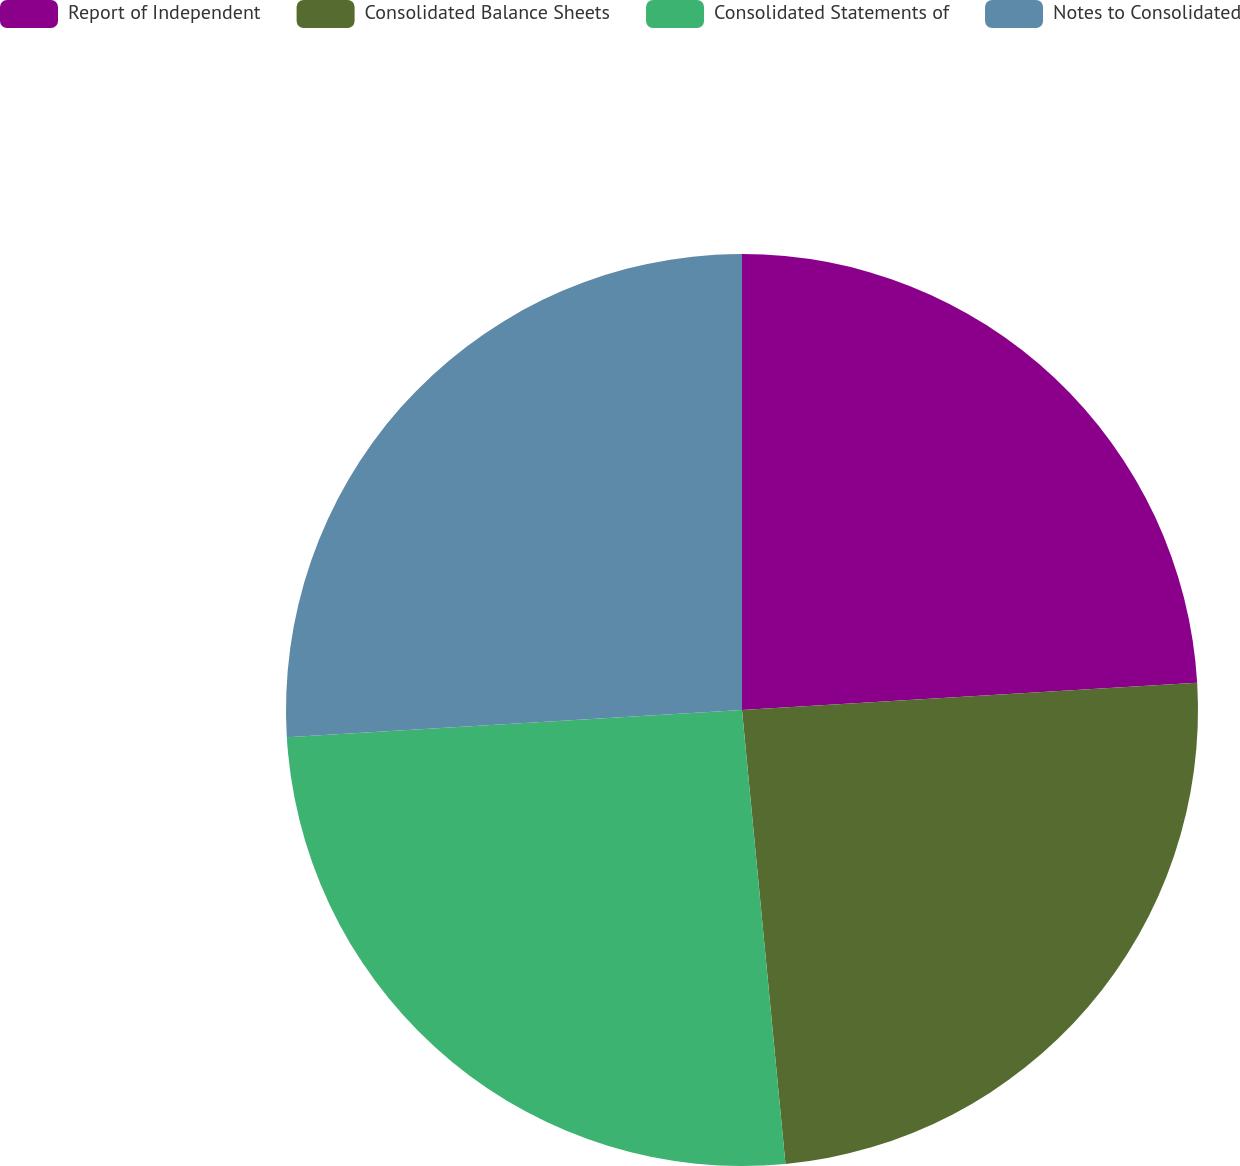Convert chart to OTSL. <chart><loc_0><loc_0><loc_500><loc_500><pie_chart><fcel>Report of Independent<fcel>Consolidated Balance Sheets<fcel>Consolidated Statements of<fcel>Notes to Consolidated<nl><fcel>24.05%<fcel>24.43%<fcel>25.57%<fcel>25.95%<nl></chart> 